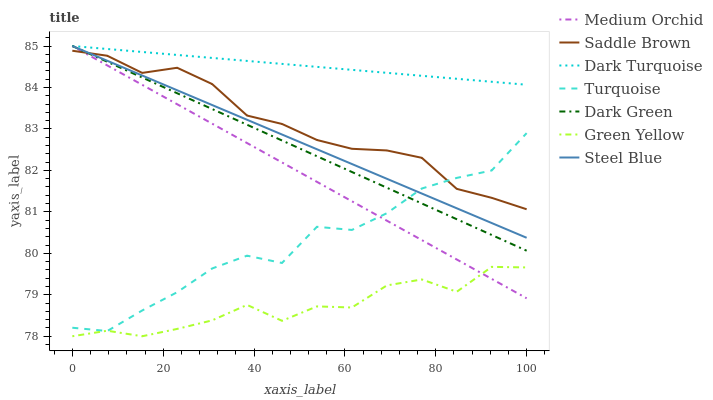Does Green Yellow have the minimum area under the curve?
Answer yes or no. Yes. Does Dark Turquoise have the maximum area under the curve?
Answer yes or no. Yes. Does Medium Orchid have the minimum area under the curve?
Answer yes or no. No. Does Medium Orchid have the maximum area under the curve?
Answer yes or no. No. Is Steel Blue the smoothest?
Answer yes or no. Yes. Is Green Yellow the roughest?
Answer yes or no. Yes. Is Dark Turquoise the smoothest?
Answer yes or no. No. Is Dark Turquoise the roughest?
Answer yes or no. No. Does Green Yellow have the lowest value?
Answer yes or no. Yes. Does Medium Orchid have the lowest value?
Answer yes or no. No. Does Dark Green have the highest value?
Answer yes or no. Yes. Does Green Yellow have the highest value?
Answer yes or no. No. Is Green Yellow less than Dark Green?
Answer yes or no. Yes. Is Dark Turquoise greater than Saddle Brown?
Answer yes or no. Yes. Does Dark Green intersect Dark Turquoise?
Answer yes or no. Yes. Is Dark Green less than Dark Turquoise?
Answer yes or no. No. Is Dark Green greater than Dark Turquoise?
Answer yes or no. No. Does Green Yellow intersect Dark Green?
Answer yes or no. No. 